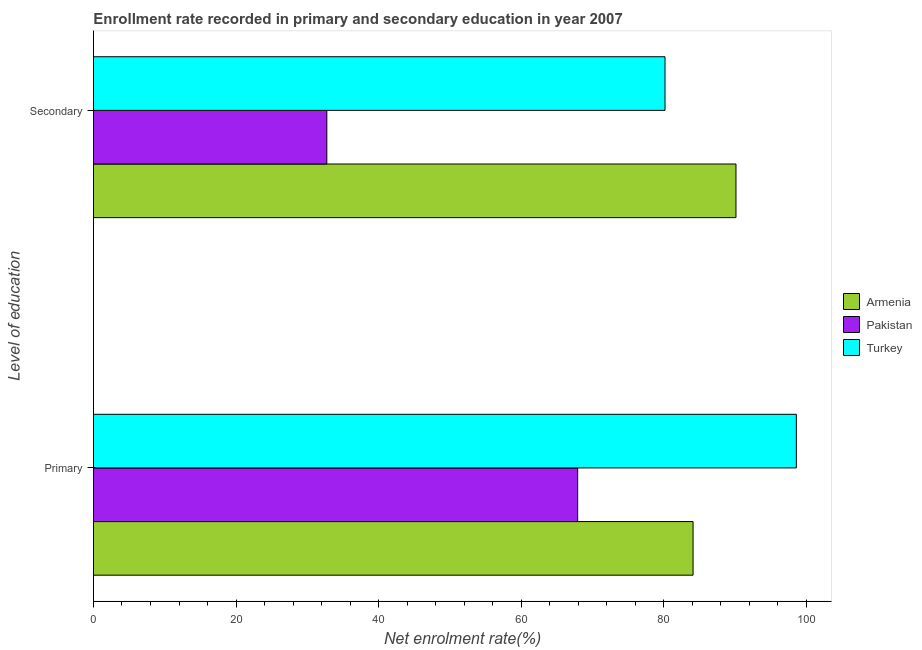How many different coloured bars are there?
Give a very brief answer. 3. How many groups of bars are there?
Provide a succinct answer. 2. Are the number of bars on each tick of the Y-axis equal?
Offer a very short reply. Yes. How many bars are there on the 2nd tick from the bottom?
Give a very brief answer. 3. What is the label of the 2nd group of bars from the top?
Your answer should be compact. Primary. What is the enrollment rate in secondary education in Pakistan?
Your answer should be compact. 32.74. Across all countries, what is the maximum enrollment rate in secondary education?
Give a very brief answer. 90.14. Across all countries, what is the minimum enrollment rate in secondary education?
Offer a very short reply. 32.74. In which country was the enrollment rate in primary education maximum?
Offer a very short reply. Turkey. What is the total enrollment rate in primary education in the graph?
Give a very brief answer. 250.66. What is the difference between the enrollment rate in secondary education in Armenia and that in Pakistan?
Provide a short and direct response. 57.4. What is the difference between the enrollment rate in secondary education in Armenia and the enrollment rate in primary education in Pakistan?
Make the answer very short. 22.21. What is the average enrollment rate in primary education per country?
Offer a very short reply. 83.55. What is the difference between the enrollment rate in secondary education and enrollment rate in primary education in Armenia?
Your response must be concise. 6.02. In how many countries, is the enrollment rate in secondary education greater than 32 %?
Keep it short and to the point. 3. What is the ratio of the enrollment rate in secondary education in Pakistan to that in Turkey?
Your response must be concise. 0.41. In how many countries, is the enrollment rate in secondary education greater than the average enrollment rate in secondary education taken over all countries?
Your answer should be very brief. 2. What does the 1st bar from the top in Secondary represents?
Ensure brevity in your answer.  Turkey. How many bars are there?
Provide a short and direct response. 6. Are all the bars in the graph horizontal?
Offer a very short reply. Yes. How many countries are there in the graph?
Offer a very short reply. 3. What is the difference between two consecutive major ticks on the X-axis?
Your answer should be compact. 20. Are the values on the major ticks of X-axis written in scientific E-notation?
Your answer should be very brief. No. Does the graph contain grids?
Keep it short and to the point. No. Where does the legend appear in the graph?
Keep it short and to the point. Center right. What is the title of the graph?
Your answer should be very brief. Enrollment rate recorded in primary and secondary education in year 2007. What is the label or title of the X-axis?
Provide a succinct answer. Net enrolment rate(%). What is the label or title of the Y-axis?
Offer a terse response. Level of education. What is the Net enrolment rate(%) of Armenia in Primary?
Offer a terse response. 84.12. What is the Net enrolment rate(%) of Pakistan in Primary?
Your answer should be very brief. 67.93. What is the Net enrolment rate(%) of Turkey in Primary?
Offer a terse response. 98.61. What is the Net enrolment rate(%) in Armenia in Secondary?
Offer a terse response. 90.14. What is the Net enrolment rate(%) of Pakistan in Secondary?
Give a very brief answer. 32.74. What is the Net enrolment rate(%) in Turkey in Secondary?
Offer a terse response. 80.18. Across all Level of education, what is the maximum Net enrolment rate(%) in Armenia?
Give a very brief answer. 90.14. Across all Level of education, what is the maximum Net enrolment rate(%) in Pakistan?
Provide a succinct answer. 67.93. Across all Level of education, what is the maximum Net enrolment rate(%) of Turkey?
Provide a short and direct response. 98.61. Across all Level of education, what is the minimum Net enrolment rate(%) of Armenia?
Provide a succinct answer. 84.12. Across all Level of education, what is the minimum Net enrolment rate(%) of Pakistan?
Your response must be concise. 32.74. Across all Level of education, what is the minimum Net enrolment rate(%) of Turkey?
Offer a terse response. 80.18. What is the total Net enrolment rate(%) of Armenia in the graph?
Provide a succinct answer. 174.26. What is the total Net enrolment rate(%) in Pakistan in the graph?
Your response must be concise. 100.67. What is the total Net enrolment rate(%) in Turkey in the graph?
Make the answer very short. 178.79. What is the difference between the Net enrolment rate(%) in Armenia in Primary and that in Secondary?
Your answer should be very brief. -6.02. What is the difference between the Net enrolment rate(%) of Pakistan in Primary and that in Secondary?
Your answer should be very brief. 35.19. What is the difference between the Net enrolment rate(%) in Turkey in Primary and that in Secondary?
Provide a succinct answer. 18.43. What is the difference between the Net enrolment rate(%) of Armenia in Primary and the Net enrolment rate(%) of Pakistan in Secondary?
Keep it short and to the point. 51.38. What is the difference between the Net enrolment rate(%) in Armenia in Primary and the Net enrolment rate(%) in Turkey in Secondary?
Keep it short and to the point. 3.94. What is the difference between the Net enrolment rate(%) of Pakistan in Primary and the Net enrolment rate(%) of Turkey in Secondary?
Provide a short and direct response. -12.25. What is the average Net enrolment rate(%) in Armenia per Level of education?
Keep it short and to the point. 87.13. What is the average Net enrolment rate(%) of Pakistan per Level of education?
Offer a terse response. 50.34. What is the average Net enrolment rate(%) in Turkey per Level of education?
Ensure brevity in your answer.  89.4. What is the difference between the Net enrolment rate(%) in Armenia and Net enrolment rate(%) in Pakistan in Primary?
Make the answer very short. 16.19. What is the difference between the Net enrolment rate(%) of Armenia and Net enrolment rate(%) of Turkey in Primary?
Offer a terse response. -14.49. What is the difference between the Net enrolment rate(%) in Pakistan and Net enrolment rate(%) in Turkey in Primary?
Offer a very short reply. -30.68. What is the difference between the Net enrolment rate(%) of Armenia and Net enrolment rate(%) of Pakistan in Secondary?
Keep it short and to the point. 57.4. What is the difference between the Net enrolment rate(%) in Armenia and Net enrolment rate(%) in Turkey in Secondary?
Keep it short and to the point. 9.96. What is the difference between the Net enrolment rate(%) in Pakistan and Net enrolment rate(%) in Turkey in Secondary?
Provide a succinct answer. -47.44. What is the ratio of the Net enrolment rate(%) in Armenia in Primary to that in Secondary?
Offer a very short reply. 0.93. What is the ratio of the Net enrolment rate(%) of Pakistan in Primary to that in Secondary?
Ensure brevity in your answer.  2.07. What is the ratio of the Net enrolment rate(%) in Turkey in Primary to that in Secondary?
Offer a terse response. 1.23. What is the difference between the highest and the second highest Net enrolment rate(%) in Armenia?
Offer a terse response. 6.02. What is the difference between the highest and the second highest Net enrolment rate(%) of Pakistan?
Your response must be concise. 35.19. What is the difference between the highest and the second highest Net enrolment rate(%) of Turkey?
Offer a very short reply. 18.43. What is the difference between the highest and the lowest Net enrolment rate(%) in Armenia?
Your response must be concise. 6.02. What is the difference between the highest and the lowest Net enrolment rate(%) of Pakistan?
Make the answer very short. 35.19. What is the difference between the highest and the lowest Net enrolment rate(%) in Turkey?
Keep it short and to the point. 18.43. 